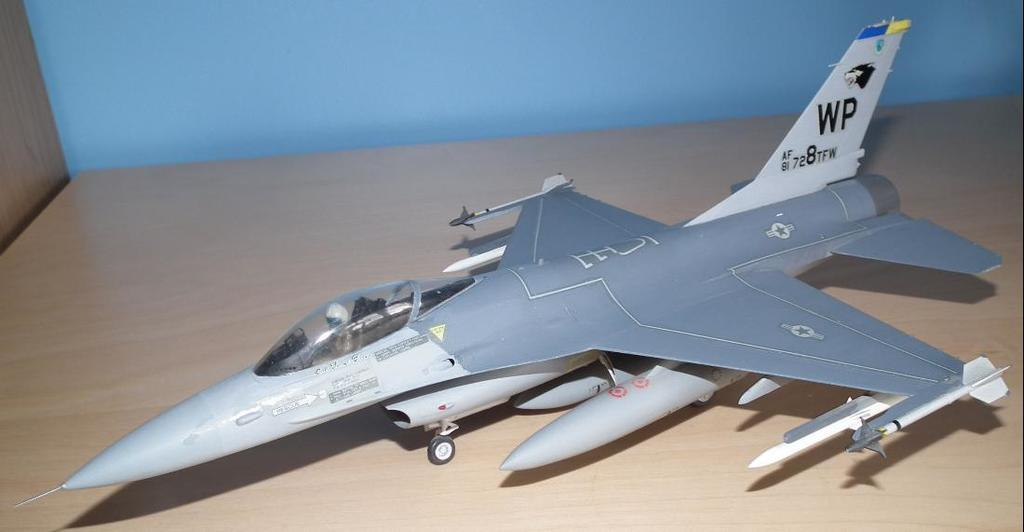<image>
Share a concise interpretation of the image provided. a WP sign on the back of a plane 